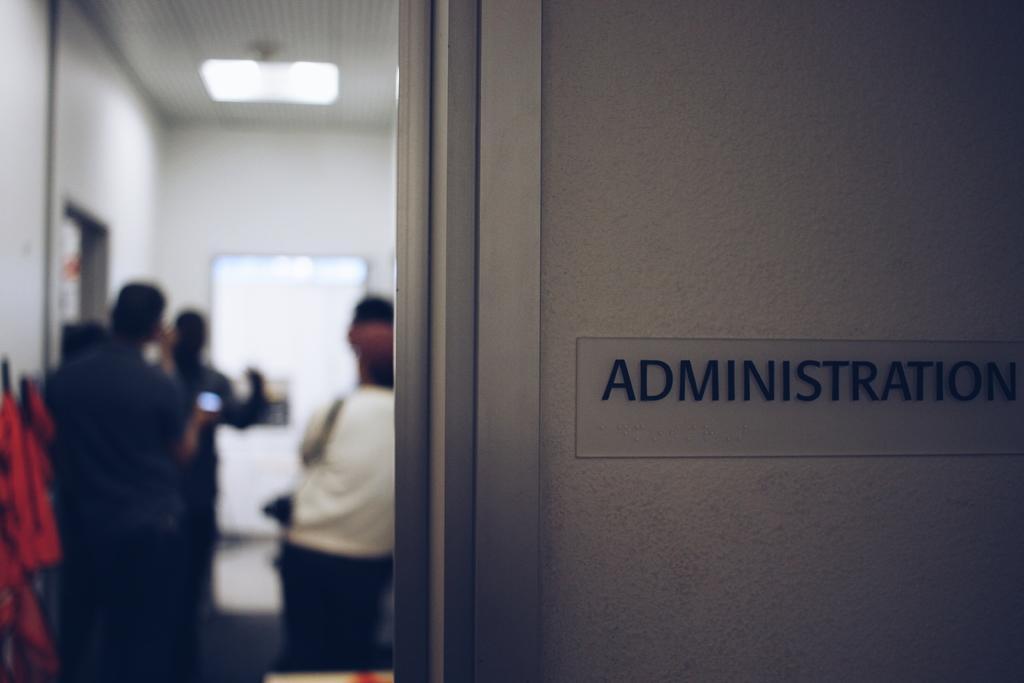In one or two sentences, can you explain what this image depicts? In this image I can see number of persons are standing, a cream colored wall and a board attached to the wall on which I can see a word " Administration" is written. In the background I can see the white colored wall, the ceiling and a light to the ceiling. 